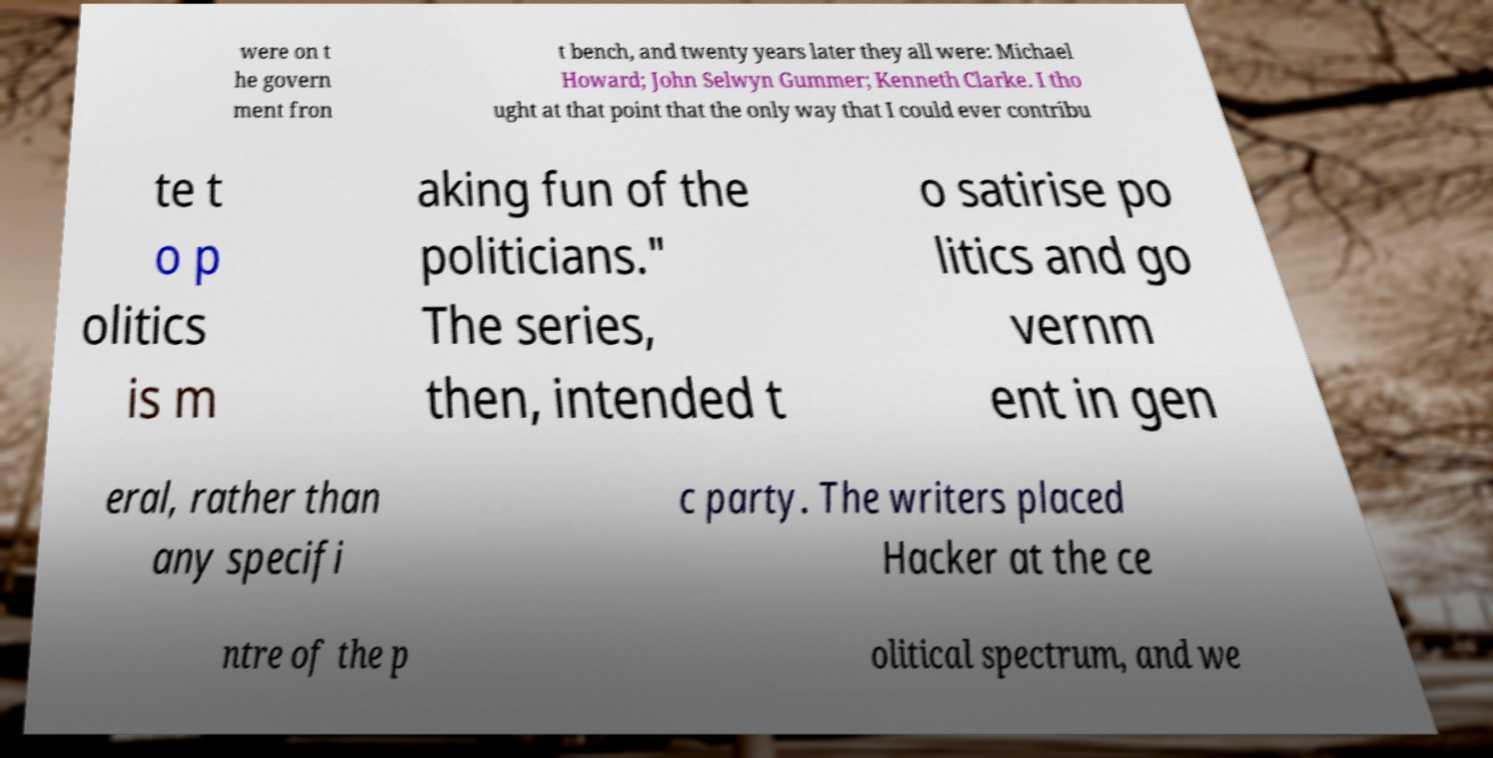What messages or text are displayed in this image? I need them in a readable, typed format. were on t he govern ment fron t bench, and twenty years later they all were: Michael Howard; John Selwyn Gummer; Kenneth Clarke. I tho ught at that point that the only way that I could ever contribu te t o p olitics is m aking fun of the politicians." The series, then, intended t o satirise po litics and go vernm ent in gen eral, rather than any specifi c party. The writers placed Hacker at the ce ntre of the p olitical spectrum, and we 